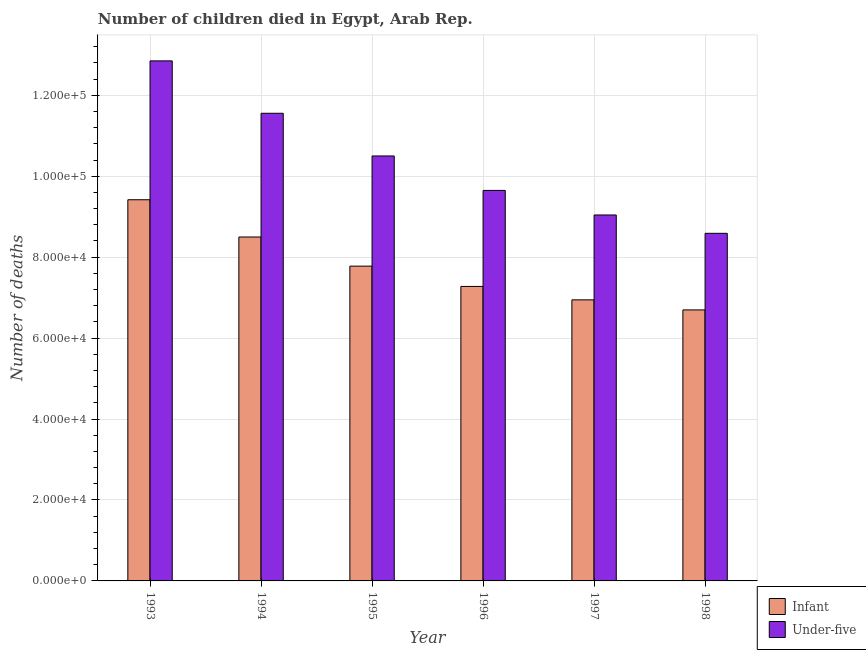How many different coloured bars are there?
Give a very brief answer. 2. Are the number of bars per tick equal to the number of legend labels?
Ensure brevity in your answer.  Yes. How many bars are there on the 2nd tick from the left?
Keep it short and to the point. 2. In how many cases, is the number of bars for a given year not equal to the number of legend labels?
Give a very brief answer. 0. What is the number of under-five deaths in 1993?
Your response must be concise. 1.28e+05. Across all years, what is the maximum number of under-five deaths?
Provide a succinct answer. 1.28e+05. Across all years, what is the minimum number of infant deaths?
Give a very brief answer. 6.70e+04. In which year was the number of infant deaths maximum?
Provide a short and direct response. 1993. What is the total number of infant deaths in the graph?
Offer a very short reply. 4.66e+05. What is the difference between the number of infant deaths in 1993 and that in 1997?
Give a very brief answer. 2.47e+04. What is the difference between the number of under-five deaths in 1997 and the number of infant deaths in 1993?
Your response must be concise. -3.81e+04. What is the average number of infant deaths per year?
Your response must be concise. 7.77e+04. In the year 1995, what is the difference between the number of infant deaths and number of under-five deaths?
Provide a succinct answer. 0. In how many years, is the number of infant deaths greater than 112000?
Offer a very short reply. 0. What is the ratio of the number of infant deaths in 1993 to that in 1994?
Keep it short and to the point. 1.11. Is the number of under-five deaths in 1993 less than that in 1997?
Offer a very short reply. No. Is the difference between the number of infant deaths in 1995 and 1996 greater than the difference between the number of under-five deaths in 1995 and 1996?
Give a very brief answer. No. What is the difference between the highest and the second highest number of under-five deaths?
Your answer should be very brief. 1.29e+04. What is the difference between the highest and the lowest number of under-five deaths?
Provide a short and direct response. 4.26e+04. What does the 2nd bar from the left in 1998 represents?
Offer a terse response. Under-five. What does the 2nd bar from the right in 1995 represents?
Provide a short and direct response. Infant. How many bars are there?
Keep it short and to the point. 12. Are all the bars in the graph horizontal?
Give a very brief answer. No. How many years are there in the graph?
Offer a very short reply. 6. Does the graph contain any zero values?
Offer a very short reply. No. How many legend labels are there?
Your response must be concise. 2. How are the legend labels stacked?
Offer a very short reply. Vertical. What is the title of the graph?
Your answer should be very brief. Number of children died in Egypt, Arab Rep. Does "Public credit registry" appear as one of the legend labels in the graph?
Offer a terse response. No. What is the label or title of the Y-axis?
Your answer should be compact. Number of deaths. What is the Number of deaths of Infant in 1993?
Make the answer very short. 9.42e+04. What is the Number of deaths in Under-five in 1993?
Your answer should be compact. 1.28e+05. What is the Number of deaths of Infant in 1994?
Give a very brief answer. 8.50e+04. What is the Number of deaths in Under-five in 1994?
Ensure brevity in your answer.  1.16e+05. What is the Number of deaths of Infant in 1995?
Your answer should be very brief. 7.78e+04. What is the Number of deaths of Under-five in 1995?
Make the answer very short. 1.05e+05. What is the Number of deaths of Infant in 1996?
Your answer should be compact. 7.28e+04. What is the Number of deaths of Under-five in 1996?
Make the answer very short. 9.65e+04. What is the Number of deaths in Infant in 1997?
Ensure brevity in your answer.  6.94e+04. What is the Number of deaths of Under-five in 1997?
Ensure brevity in your answer.  9.04e+04. What is the Number of deaths of Infant in 1998?
Provide a short and direct response. 6.70e+04. What is the Number of deaths of Under-five in 1998?
Give a very brief answer. 8.59e+04. Across all years, what is the maximum Number of deaths in Infant?
Provide a short and direct response. 9.42e+04. Across all years, what is the maximum Number of deaths in Under-five?
Your answer should be compact. 1.28e+05. Across all years, what is the minimum Number of deaths in Infant?
Provide a short and direct response. 6.70e+04. Across all years, what is the minimum Number of deaths in Under-five?
Your answer should be compact. 8.59e+04. What is the total Number of deaths in Infant in the graph?
Offer a very short reply. 4.66e+05. What is the total Number of deaths in Under-five in the graph?
Provide a succinct answer. 6.22e+05. What is the difference between the Number of deaths in Infant in 1993 and that in 1994?
Keep it short and to the point. 9205. What is the difference between the Number of deaths in Under-five in 1993 and that in 1994?
Your response must be concise. 1.29e+04. What is the difference between the Number of deaths of Infant in 1993 and that in 1995?
Your response must be concise. 1.64e+04. What is the difference between the Number of deaths of Under-five in 1993 and that in 1995?
Give a very brief answer. 2.35e+04. What is the difference between the Number of deaths of Infant in 1993 and that in 1996?
Ensure brevity in your answer.  2.14e+04. What is the difference between the Number of deaths of Under-five in 1993 and that in 1996?
Your response must be concise. 3.20e+04. What is the difference between the Number of deaths of Infant in 1993 and that in 1997?
Provide a short and direct response. 2.47e+04. What is the difference between the Number of deaths of Under-five in 1993 and that in 1997?
Your answer should be very brief. 3.81e+04. What is the difference between the Number of deaths in Infant in 1993 and that in 1998?
Offer a terse response. 2.72e+04. What is the difference between the Number of deaths in Under-five in 1993 and that in 1998?
Ensure brevity in your answer.  4.26e+04. What is the difference between the Number of deaths in Infant in 1994 and that in 1995?
Your answer should be compact. 7199. What is the difference between the Number of deaths in Under-five in 1994 and that in 1995?
Your response must be concise. 1.05e+04. What is the difference between the Number of deaths of Infant in 1994 and that in 1996?
Offer a very short reply. 1.22e+04. What is the difference between the Number of deaths in Under-five in 1994 and that in 1996?
Your answer should be compact. 1.91e+04. What is the difference between the Number of deaths in Infant in 1994 and that in 1997?
Keep it short and to the point. 1.55e+04. What is the difference between the Number of deaths of Under-five in 1994 and that in 1997?
Provide a succinct answer. 2.51e+04. What is the difference between the Number of deaths of Infant in 1994 and that in 1998?
Offer a very short reply. 1.80e+04. What is the difference between the Number of deaths in Under-five in 1994 and that in 1998?
Your answer should be compact. 2.97e+04. What is the difference between the Number of deaths in Infant in 1995 and that in 1996?
Provide a short and direct response. 5016. What is the difference between the Number of deaths in Under-five in 1995 and that in 1996?
Offer a very short reply. 8510. What is the difference between the Number of deaths in Infant in 1995 and that in 1997?
Your response must be concise. 8333. What is the difference between the Number of deaths of Under-five in 1995 and that in 1997?
Offer a terse response. 1.46e+04. What is the difference between the Number of deaths of Infant in 1995 and that in 1998?
Your answer should be compact. 1.08e+04. What is the difference between the Number of deaths of Under-five in 1995 and that in 1998?
Your answer should be compact. 1.91e+04. What is the difference between the Number of deaths of Infant in 1996 and that in 1997?
Offer a terse response. 3317. What is the difference between the Number of deaths in Under-five in 1996 and that in 1997?
Your answer should be compact. 6071. What is the difference between the Number of deaths in Infant in 1996 and that in 1998?
Provide a short and direct response. 5801. What is the difference between the Number of deaths in Under-five in 1996 and that in 1998?
Your response must be concise. 1.06e+04. What is the difference between the Number of deaths of Infant in 1997 and that in 1998?
Offer a very short reply. 2484. What is the difference between the Number of deaths of Under-five in 1997 and that in 1998?
Make the answer very short. 4531. What is the difference between the Number of deaths of Infant in 1993 and the Number of deaths of Under-five in 1994?
Provide a succinct answer. -2.14e+04. What is the difference between the Number of deaths in Infant in 1993 and the Number of deaths in Under-five in 1995?
Offer a very short reply. -1.08e+04. What is the difference between the Number of deaths in Infant in 1993 and the Number of deaths in Under-five in 1996?
Keep it short and to the point. -2306. What is the difference between the Number of deaths of Infant in 1993 and the Number of deaths of Under-five in 1997?
Offer a terse response. 3765. What is the difference between the Number of deaths of Infant in 1993 and the Number of deaths of Under-five in 1998?
Ensure brevity in your answer.  8296. What is the difference between the Number of deaths in Infant in 1994 and the Number of deaths in Under-five in 1995?
Offer a terse response. -2.00e+04. What is the difference between the Number of deaths of Infant in 1994 and the Number of deaths of Under-five in 1996?
Give a very brief answer. -1.15e+04. What is the difference between the Number of deaths of Infant in 1994 and the Number of deaths of Under-five in 1997?
Offer a very short reply. -5440. What is the difference between the Number of deaths of Infant in 1994 and the Number of deaths of Under-five in 1998?
Provide a succinct answer. -909. What is the difference between the Number of deaths in Infant in 1995 and the Number of deaths in Under-five in 1996?
Ensure brevity in your answer.  -1.87e+04. What is the difference between the Number of deaths in Infant in 1995 and the Number of deaths in Under-five in 1997?
Your answer should be compact. -1.26e+04. What is the difference between the Number of deaths of Infant in 1995 and the Number of deaths of Under-five in 1998?
Your response must be concise. -8108. What is the difference between the Number of deaths in Infant in 1996 and the Number of deaths in Under-five in 1997?
Your response must be concise. -1.77e+04. What is the difference between the Number of deaths of Infant in 1996 and the Number of deaths of Under-five in 1998?
Your answer should be very brief. -1.31e+04. What is the difference between the Number of deaths of Infant in 1997 and the Number of deaths of Under-five in 1998?
Provide a short and direct response. -1.64e+04. What is the average Number of deaths of Infant per year?
Keep it short and to the point. 7.77e+04. What is the average Number of deaths in Under-five per year?
Offer a terse response. 1.04e+05. In the year 1993, what is the difference between the Number of deaths of Infant and Number of deaths of Under-five?
Make the answer very short. -3.43e+04. In the year 1994, what is the difference between the Number of deaths in Infant and Number of deaths in Under-five?
Provide a short and direct response. -3.06e+04. In the year 1995, what is the difference between the Number of deaths of Infant and Number of deaths of Under-five?
Give a very brief answer. -2.72e+04. In the year 1996, what is the difference between the Number of deaths of Infant and Number of deaths of Under-five?
Give a very brief answer. -2.37e+04. In the year 1997, what is the difference between the Number of deaths of Infant and Number of deaths of Under-five?
Your response must be concise. -2.10e+04. In the year 1998, what is the difference between the Number of deaths in Infant and Number of deaths in Under-five?
Your answer should be compact. -1.89e+04. What is the ratio of the Number of deaths of Infant in 1993 to that in 1994?
Offer a terse response. 1.11. What is the ratio of the Number of deaths of Under-five in 1993 to that in 1994?
Offer a very short reply. 1.11. What is the ratio of the Number of deaths in Infant in 1993 to that in 1995?
Keep it short and to the point. 1.21. What is the ratio of the Number of deaths of Under-five in 1993 to that in 1995?
Your answer should be compact. 1.22. What is the ratio of the Number of deaths of Infant in 1993 to that in 1996?
Keep it short and to the point. 1.29. What is the ratio of the Number of deaths of Under-five in 1993 to that in 1996?
Your response must be concise. 1.33. What is the ratio of the Number of deaths in Infant in 1993 to that in 1997?
Your answer should be very brief. 1.36. What is the ratio of the Number of deaths of Under-five in 1993 to that in 1997?
Your answer should be compact. 1.42. What is the ratio of the Number of deaths of Infant in 1993 to that in 1998?
Make the answer very short. 1.41. What is the ratio of the Number of deaths of Under-five in 1993 to that in 1998?
Offer a very short reply. 1.5. What is the ratio of the Number of deaths of Infant in 1994 to that in 1995?
Provide a succinct answer. 1.09. What is the ratio of the Number of deaths of Under-five in 1994 to that in 1995?
Your answer should be very brief. 1.1. What is the ratio of the Number of deaths in Infant in 1994 to that in 1996?
Provide a succinct answer. 1.17. What is the ratio of the Number of deaths in Under-five in 1994 to that in 1996?
Your response must be concise. 1.2. What is the ratio of the Number of deaths in Infant in 1994 to that in 1997?
Ensure brevity in your answer.  1.22. What is the ratio of the Number of deaths of Under-five in 1994 to that in 1997?
Keep it short and to the point. 1.28. What is the ratio of the Number of deaths of Infant in 1994 to that in 1998?
Provide a succinct answer. 1.27. What is the ratio of the Number of deaths of Under-five in 1994 to that in 1998?
Your answer should be compact. 1.35. What is the ratio of the Number of deaths of Infant in 1995 to that in 1996?
Offer a terse response. 1.07. What is the ratio of the Number of deaths of Under-five in 1995 to that in 1996?
Keep it short and to the point. 1.09. What is the ratio of the Number of deaths of Infant in 1995 to that in 1997?
Provide a succinct answer. 1.12. What is the ratio of the Number of deaths of Under-five in 1995 to that in 1997?
Your answer should be very brief. 1.16. What is the ratio of the Number of deaths of Infant in 1995 to that in 1998?
Offer a very short reply. 1.16. What is the ratio of the Number of deaths in Under-five in 1995 to that in 1998?
Your response must be concise. 1.22. What is the ratio of the Number of deaths of Infant in 1996 to that in 1997?
Ensure brevity in your answer.  1.05. What is the ratio of the Number of deaths of Under-five in 1996 to that in 1997?
Your answer should be very brief. 1.07. What is the ratio of the Number of deaths in Infant in 1996 to that in 1998?
Keep it short and to the point. 1.09. What is the ratio of the Number of deaths in Under-five in 1996 to that in 1998?
Give a very brief answer. 1.12. What is the ratio of the Number of deaths in Infant in 1997 to that in 1998?
Offer a very short reply. 1.04. What is the ratio of the Number of deaths in Under-five in 1997 to that in 1998?
Give a very brief answer. 1.05. What is the difference between the highest and the second highest Number of deaths in Infant?
Make the answer very short. 9205. What is the difference between the highest and the second highest Number of deaths of Under-five?
Your response must be concise. 1.29e+04. What is the difference between the highest and the lowest Number of deaths in Infant?
Provide a succinct answer. 2.72e+04. What is the difference between the highest and the lowest Number of deaths of Under-five?
Your response must be concise. 4.26e+04. 